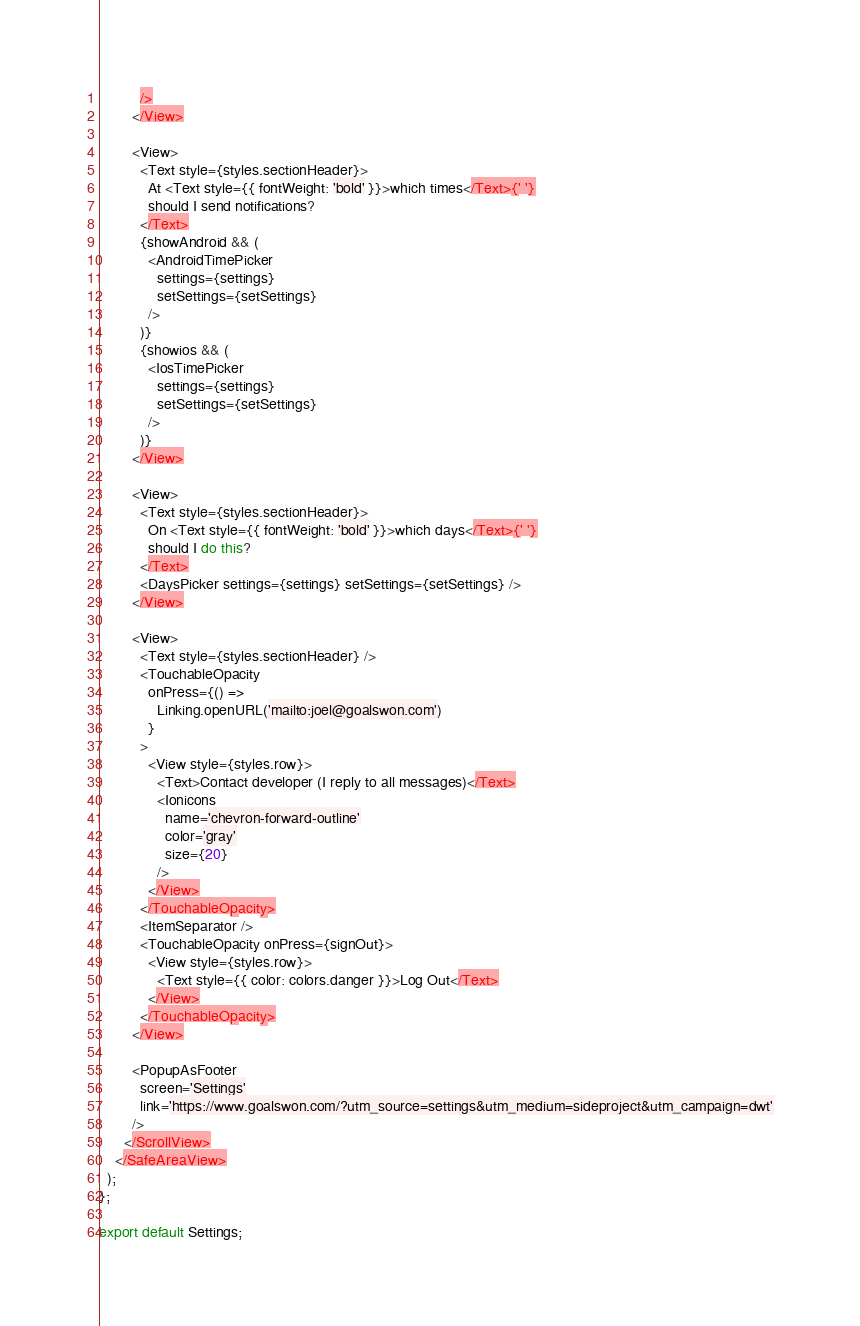<code> <loc_0><loc_0><loc_500><loc_500><_JavaScript_>          />
        </View>

        <View>
          <Text style={styles.sectionHeader}>
            At <Text style={{ fontWeight: 'bold' }}>which times</Text>{' '}
            should I send notifications?
          </Text>
          {showAndroid && (
            <AndroidTimePicker
              settings={settings}
              setSettings={setSettings}
            />
          )}
          {showios && (
            <IosTimePicker
              settings={settings}
              setSettings={setSettings}
            />
          )}
        </View>

        <View>
          <Text style={styles.sectionHeader}>
            On <Text style={{ fontWeight: 'bold' }}>which days</Text>{' '}
            should I do this?
          </Text>
          <DaysPicker settings={settings} setSettings={setSettings} />
        </View>

        <View>
          <Text style={styles.sectionHeader} />
          <TouchableOpacity
            onPress={() =>
              Linking.openURL('mailto:joel@goalswon.com')
            }
          >
            <View style={styles.row}>
              <Text>Contact developer (I reply to all messages)</Text>
              <Ionicons
                name='chevron-forward-outline'
                color='gray'
                size={20}
              />
            </View>
          </TouchableOpacity>
          <ItemSeparator />
          <TouchableOpacity onPress={signOut}>
            <View style={styles.row}>
              <Text style={{ color: colors.danger }}>Log Out</Text>
            </View>
          </TouchableOpacity>
        </View>

        <PopupAsFooter
          screen='Settings'
          link='https://www.goalswon.com/?utm_source=settings&utm_medium=sideproject&utm_campaign=dwt'
        />
      </ScrollView>
    </SafeAreaView>
  );
};

export default Settings;
</code> 